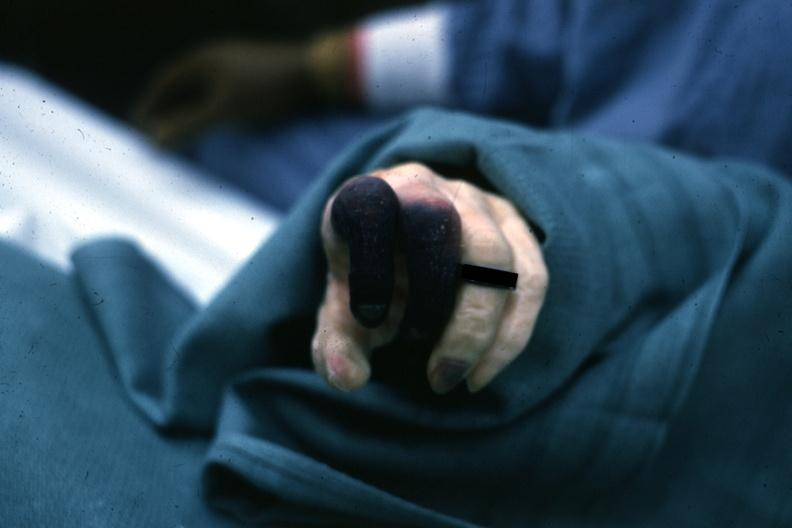re extremities present?
Answer the question using a single word or phrase. Yes 